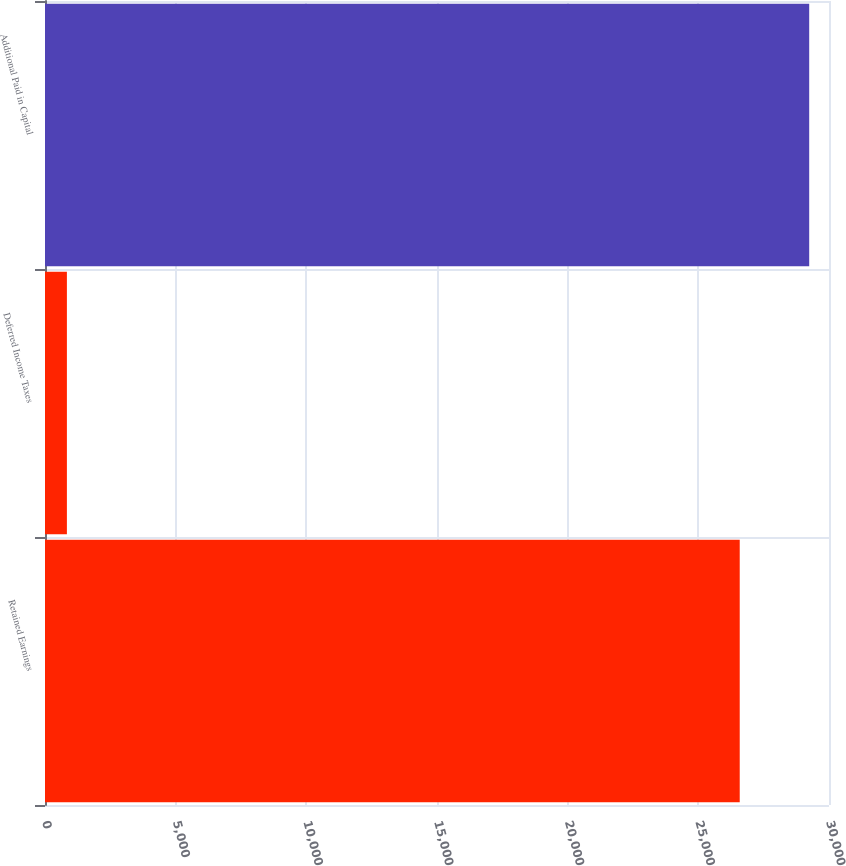<chart> <loc_0><loc_0><loc_500><loc_500><bar_chart><fcel>Retained Earnings<fcel>Deferred Income Taxes<fcel>Additional Paid in Capital<nl><fcel>26584<fcel>838<fcel>29242.4<nl></chart> 